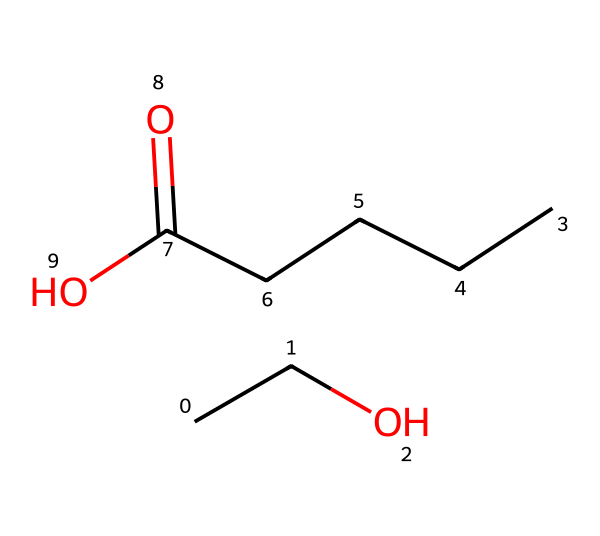What is the molecular formula of this compound? To determine the molecular formula, we can count the number of each type of atom in the SMILES structure. The structure includes two carbon (C) atoms from "CC" and five additional carbon (C) atoms from "CCCCC", resulting in a total of seven carbon atoms. There are also six hydrogen (H) atoms and two oxygen (O) atoms present. This results in the molecular formula C7H14O2.
Answer: C7H14O2 How many carbon atoms are in this molecule? By counting the carbon representations in the SMILES structure, we see "CC" indicating 2 carbons and "CCCCC" indicating 5 more carbons, adding up to a total of 7 carbon atoms.
Answer: 7 What type of functional group is present in this molecule? The structure exhibits a carboxylic acid functional group due to the "CCCC(=O)O" segment, which includes a carbonyl (C=O) and a hydroxyl (–OH) group. This indicates the presence of a carboxylic acid functional group.
Answer: carboxylic acid What is the longest carbon chain in this compound? In the SMILES representation, the molecule contains a straight chain of five carbons in "CCCCC". This is the longest continuous carbon chain present in the structure.
Answer: 5 How many oxygen atoms are in the molecule? The SMILES notation shows "O" twice, indicating the presence of two oxygen atoms in the chemical structure.
Answer: 2 What is the total number of hydrogen atoms in this molecule? From the carbon count and structure, we can apply the general rule for saturated compounds: each carbon typically bonds with enough hydrogens to make four total bonds. With 7 carbons (C7), the total number of hydrogen atoms can be deduced from the structure and is confirmed to be 14, as per previous observations.
Answer: 14 